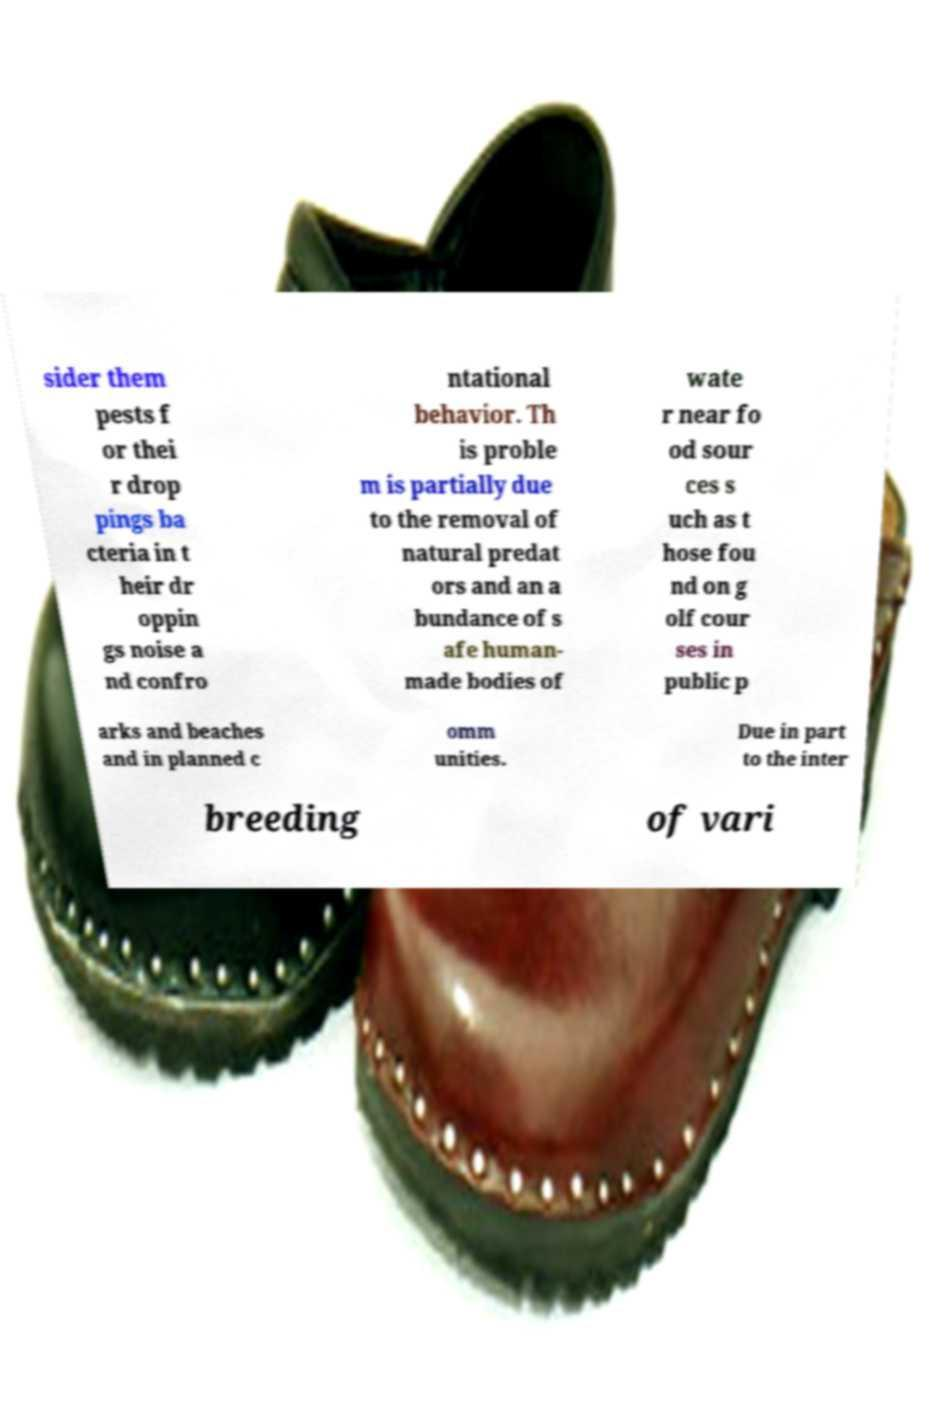Can you accurately transcribe the text from the provided image for me? sider them pests f or thei r drop pings ba cteria in t heir dr oppin gs noise a nd confro ntational behavior. Th is proble m is partially due to the removal of natural predat ors and an a bundance of s afe human- made bodies of wate r near fo od sour ces s uch as t hose fou nd on g olf cour ses in public p arks and beaches and in planned c omm unities. Due in part to the inter breeding of vari 